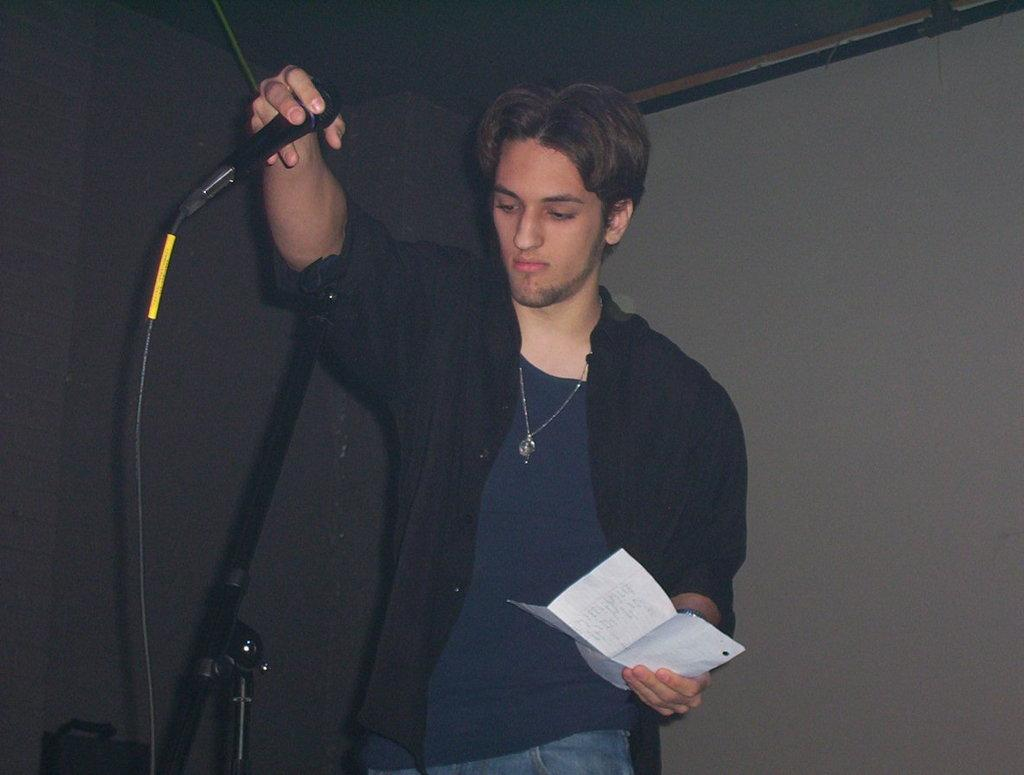What is the man in the image holding in his hand? The man is holding a paper and a microphone in the image. What might the man be doing with the microphone? The man might be using the microphone for speaking or presenting something. What type of muscle is visible on the man's arm in the image? There is no muscle visible on the man's arm in the image. What is the man selecting from the basket in the image? There is no basket present in the image. 